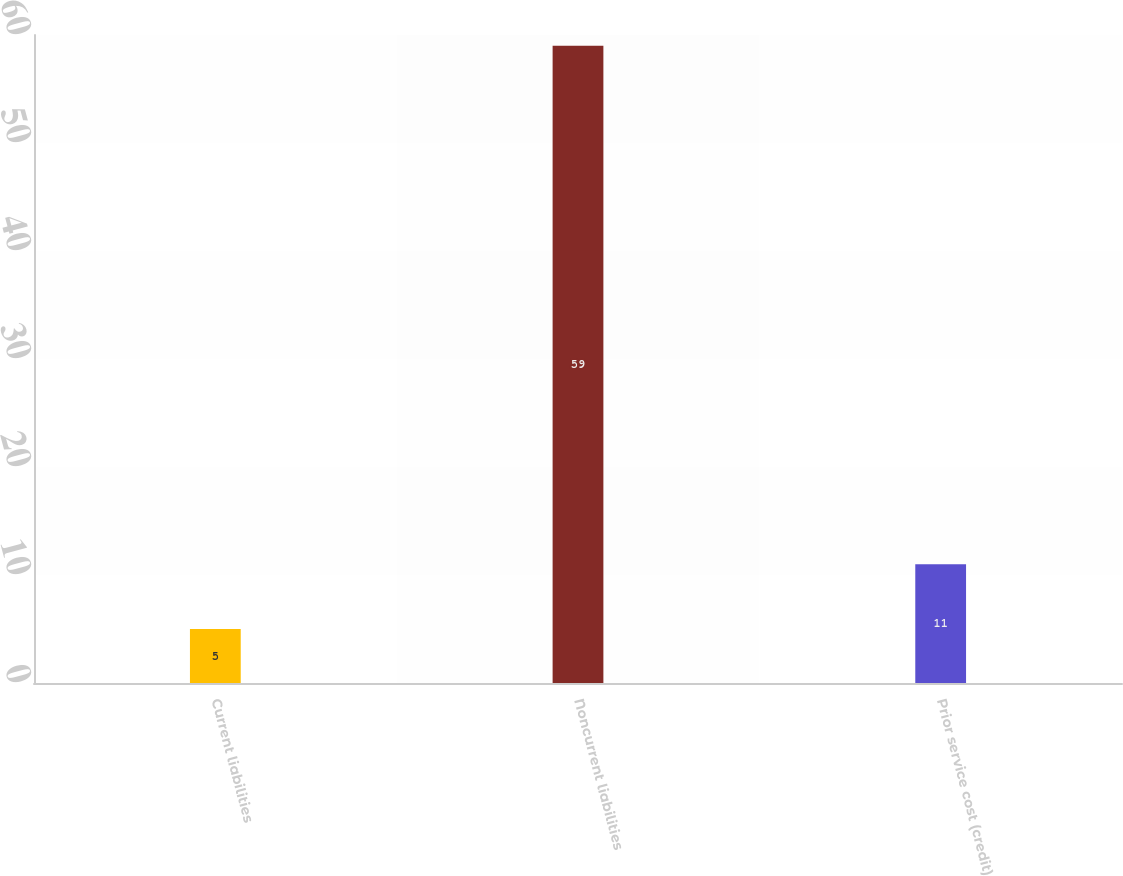Convert chart. <chart><loc_0><loc_0><loc_500><loc_500><bar_chart><fcel>Current liabilities<fcel>Noncurrent liabilities<fcel>Prior service cost (credit)<nl><fcel>5<fcel>59<fcel>11<nl></chart> 